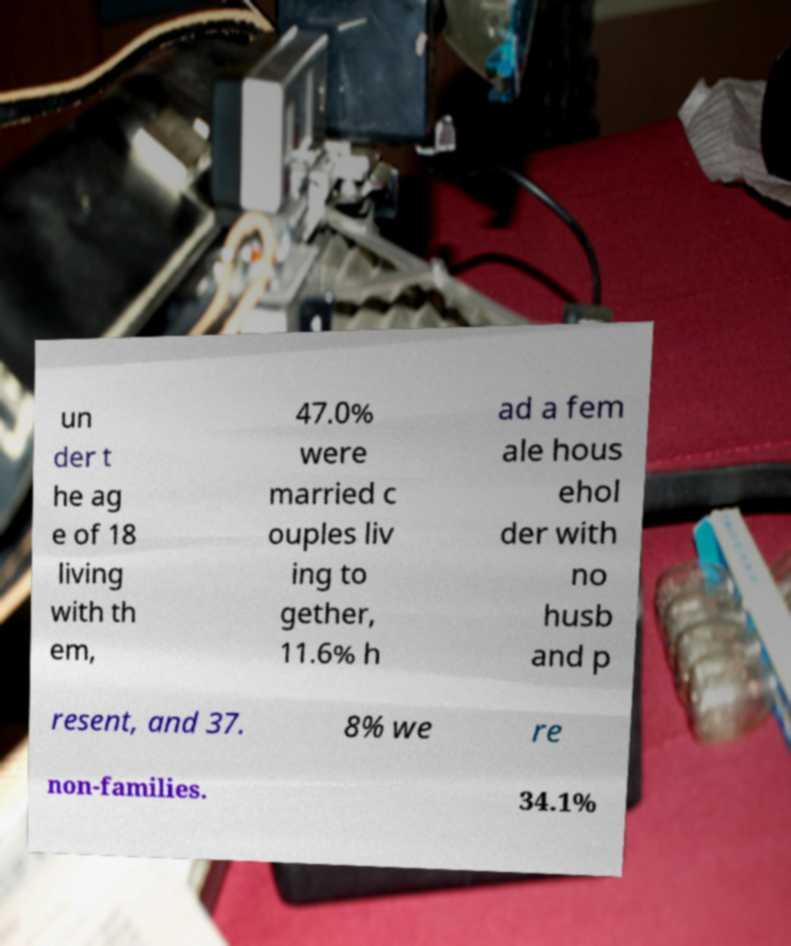Could you extract and type out the text from this image? un der t he ag e of 18 living with th em, 47.0% were married c ouples liv ing to gether, 11.6% h ad a fem ale hous ehol der with no husb and p resent, and 37. 8% we re non-families. 34.1% 